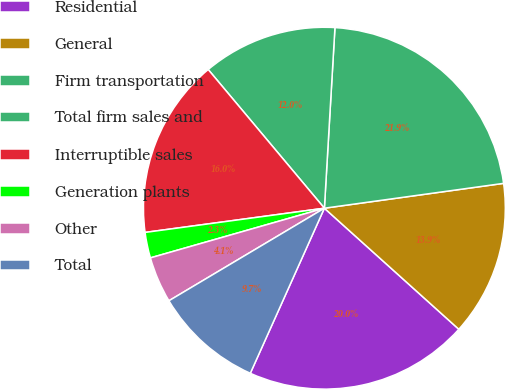Convert chart. <chart><loc_0><loc_0><loc_500><loc_500><pie_chart><fcel>Residential<fcel>General<fcel>Firm transportation<fcel>Total firm sales and<fcel>Interruptible sales<fcel>Generation plants<fcel>Other<fcel>Total<nl><fcel>20.05%<fcel>13.86%<fcel>21.88%<fcel>12.03%<fcel>16.04%<fcel>2.29%<fcel>4.12%<fcel>9.74%<nl></chart> 